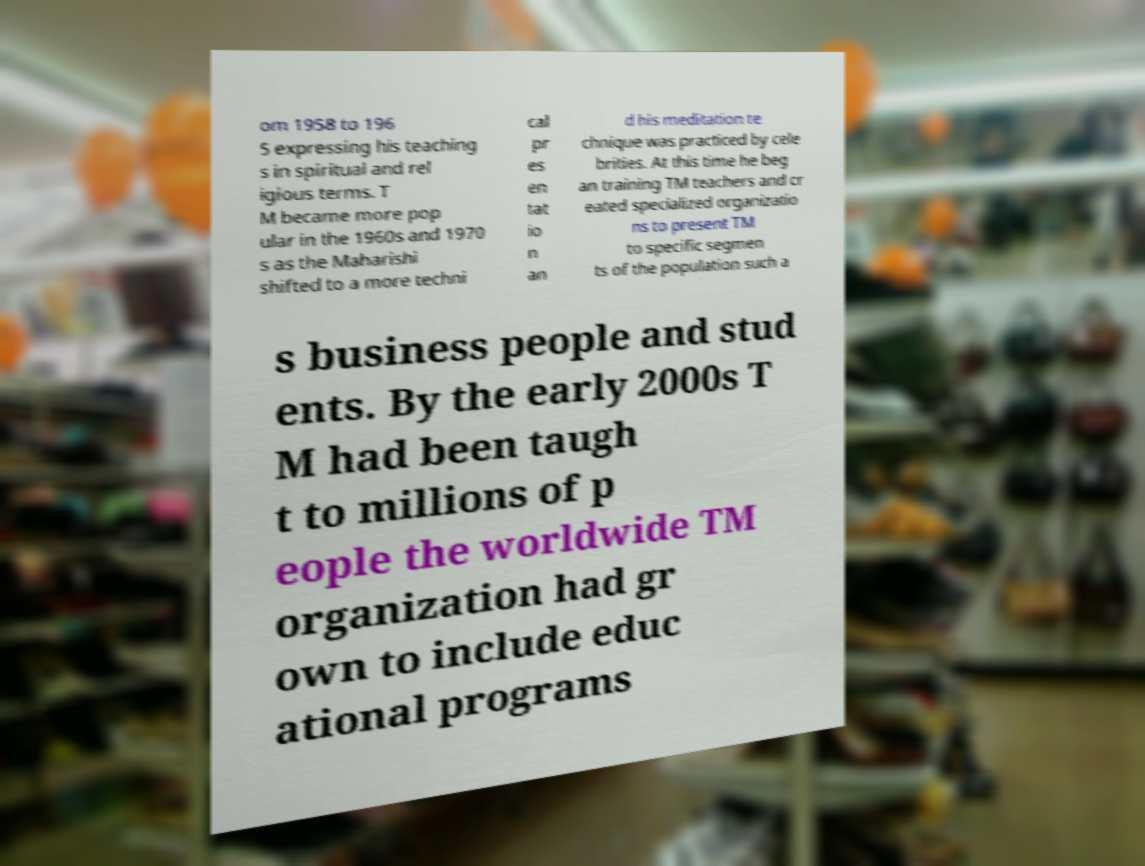For documentation purposes, I need the text within this image transcribed. Could you provide that? om 1958 to 196 5 expressing his teaching s in spiritual and rel igious terms. T M became more pop ular in the 1960s and 1970 s as the Maharishi shifted to a more techni cal pr es en tat io n an d his meditation te chnique was practiced by cele brities. At this time he beg an training TM teachers and cr eated specialized organizatio ns to present TM to specific segmen ts of the population such a s business people and stud ents. By the early 2000s T M had been taugh t to millions of p eople the worldwide TM organization had gr own to include educ ational programs 